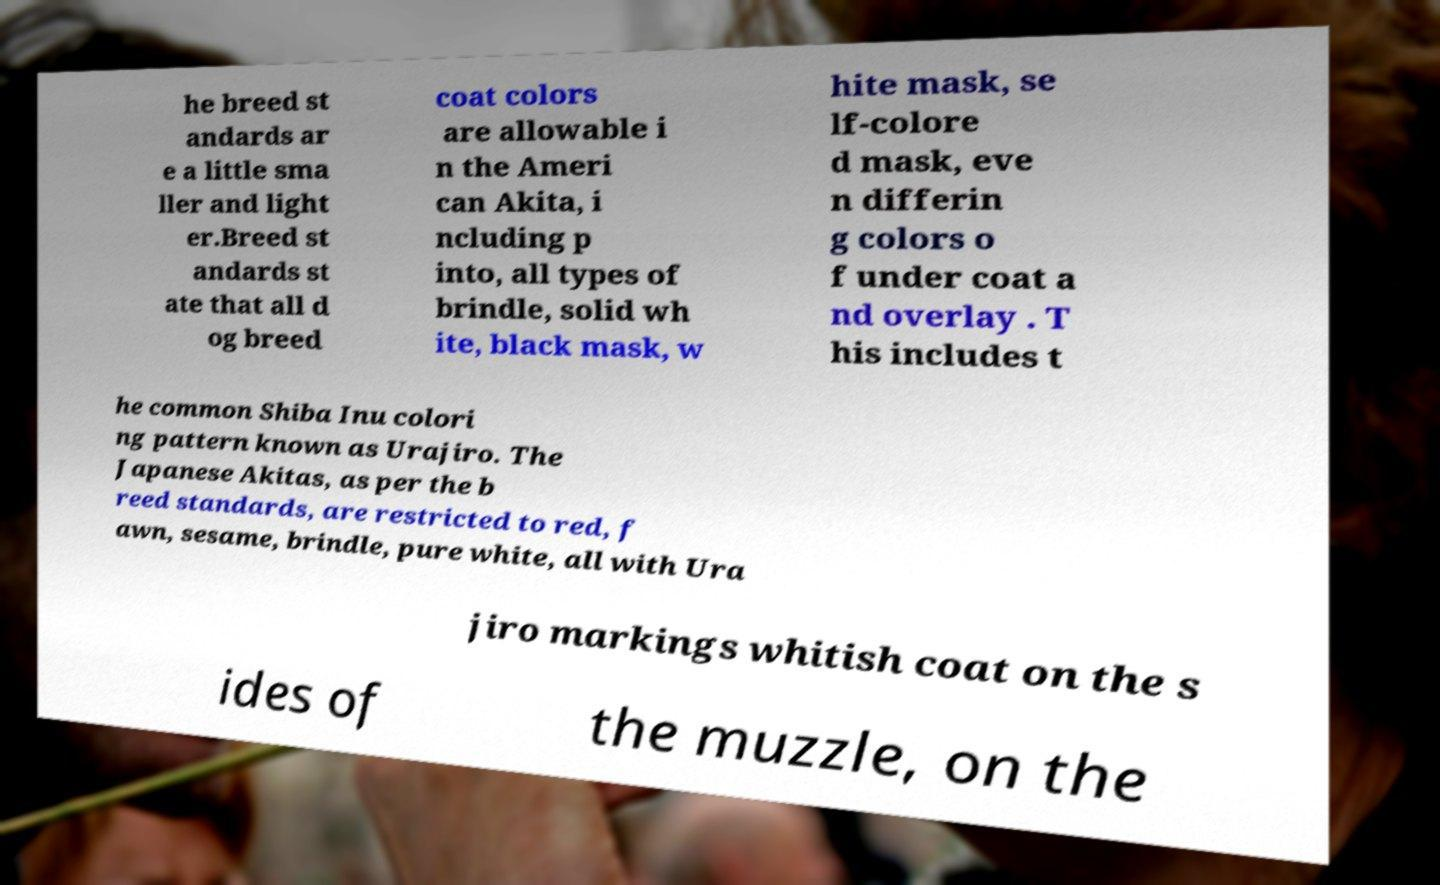Could you assist in decoding the text presented in this image and type it out clearly? he breed st andards ar e a little sma ller and light er.Breed st andards st ate that all d og breed coat colors are allowable i n the Ameri can Akita, i ncluding p into, all types of brindle, solid wh ite, black mask, w hite mask, se lf-colore d mask, eve n differin g colors o f under coat a nd overlay . T his includes t he common Shiba Inu colori ng pattern known as Urajiro. The Japanese Akitas, as per the b reed standards, are restricted to red, f awn, sesame, brindle, pure white, all with Ura jiro markings whitish coat on the s ides of the muzzle, on the 